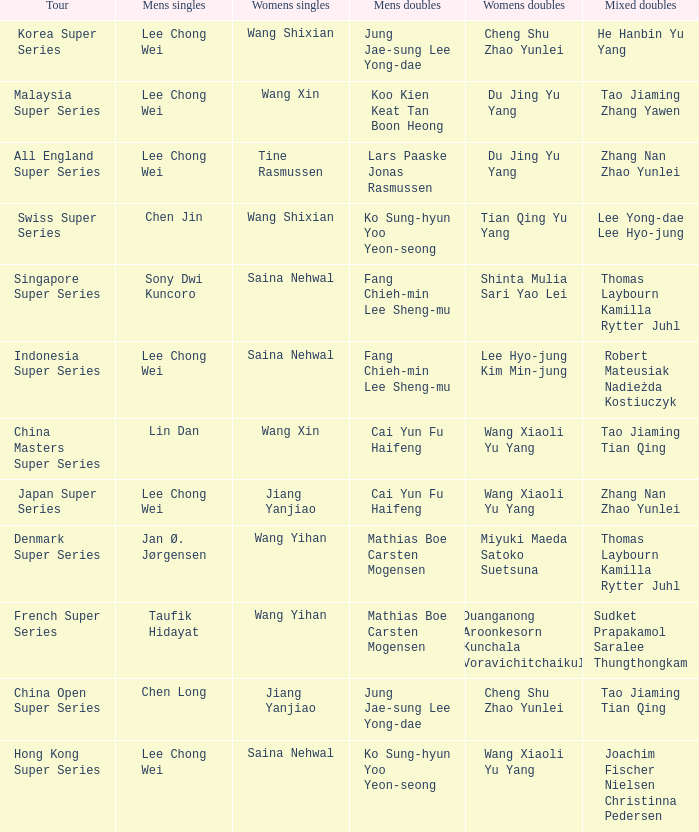Who are the mixed doubles players on the korea super series circuit? He Hanbin Yu Yang. 